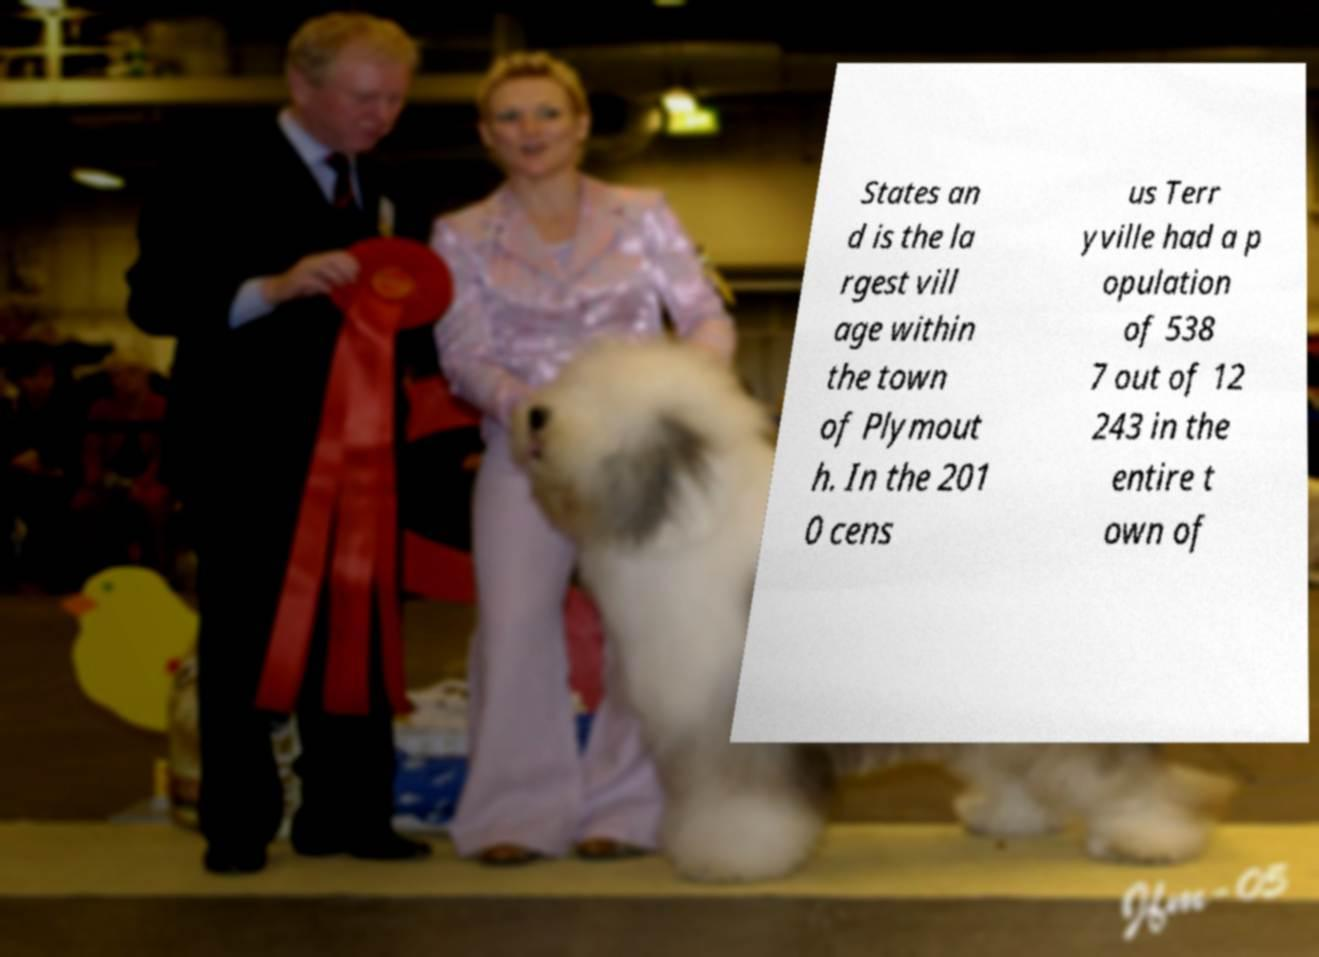What messages or text are displayed in this image? I need them in a readable, typed format. States an d is the la rgest vill age within the town of Plymout h. In the 201 0 cens us Terr yville had a p opulation of 538 7 out of 12 243 in the entire t own of 